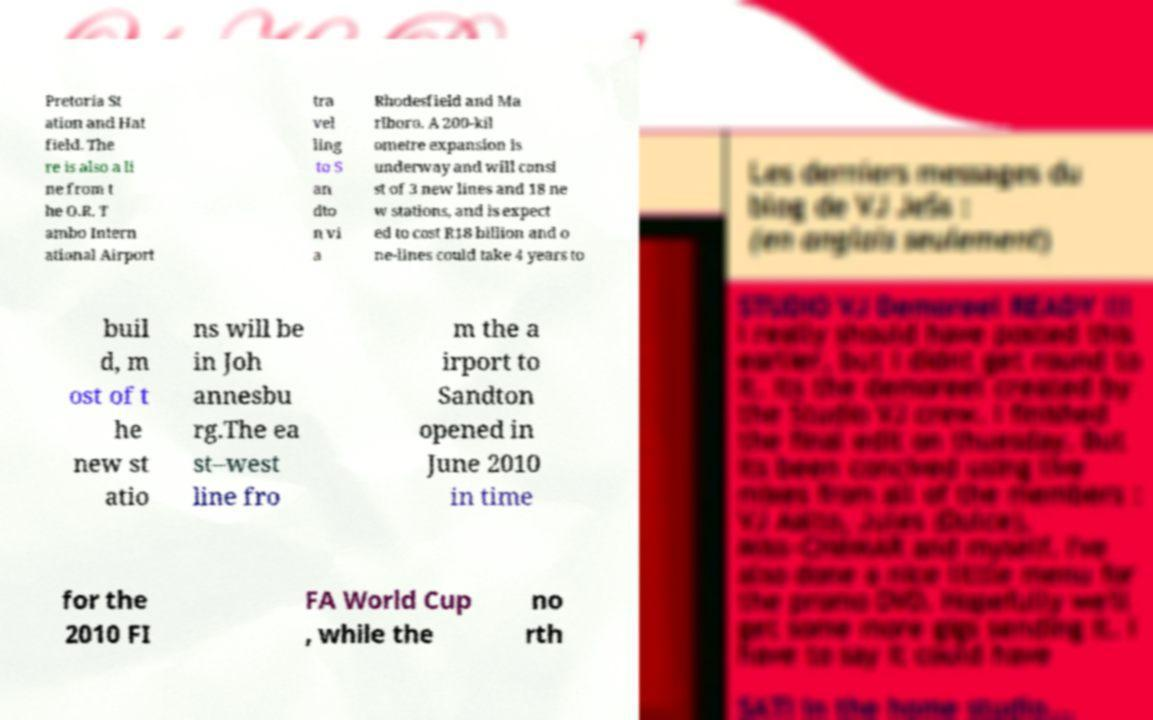Please identify and transcribe the text found in this image. Pretoria St ation and Hat field. The re is also a li ne from t he O.R. T ambo Intern ational Airport tra vel ling to S an dto n vi a Rhodesfield and Ma rlboro. A 200-kil ometre expansion is underway and will consi st of 3 new lines and 18 ne w stations, and is expect ed to cost R18 billion and o ne-lines could take 4 years to buil d, m ost of t he new st atio ns will be in Joh annesbu rg.The ea st–west line fro m the a irport to Sandton opened in June 2010 in time for the 2010 FI FA World Cup , while the no rth 